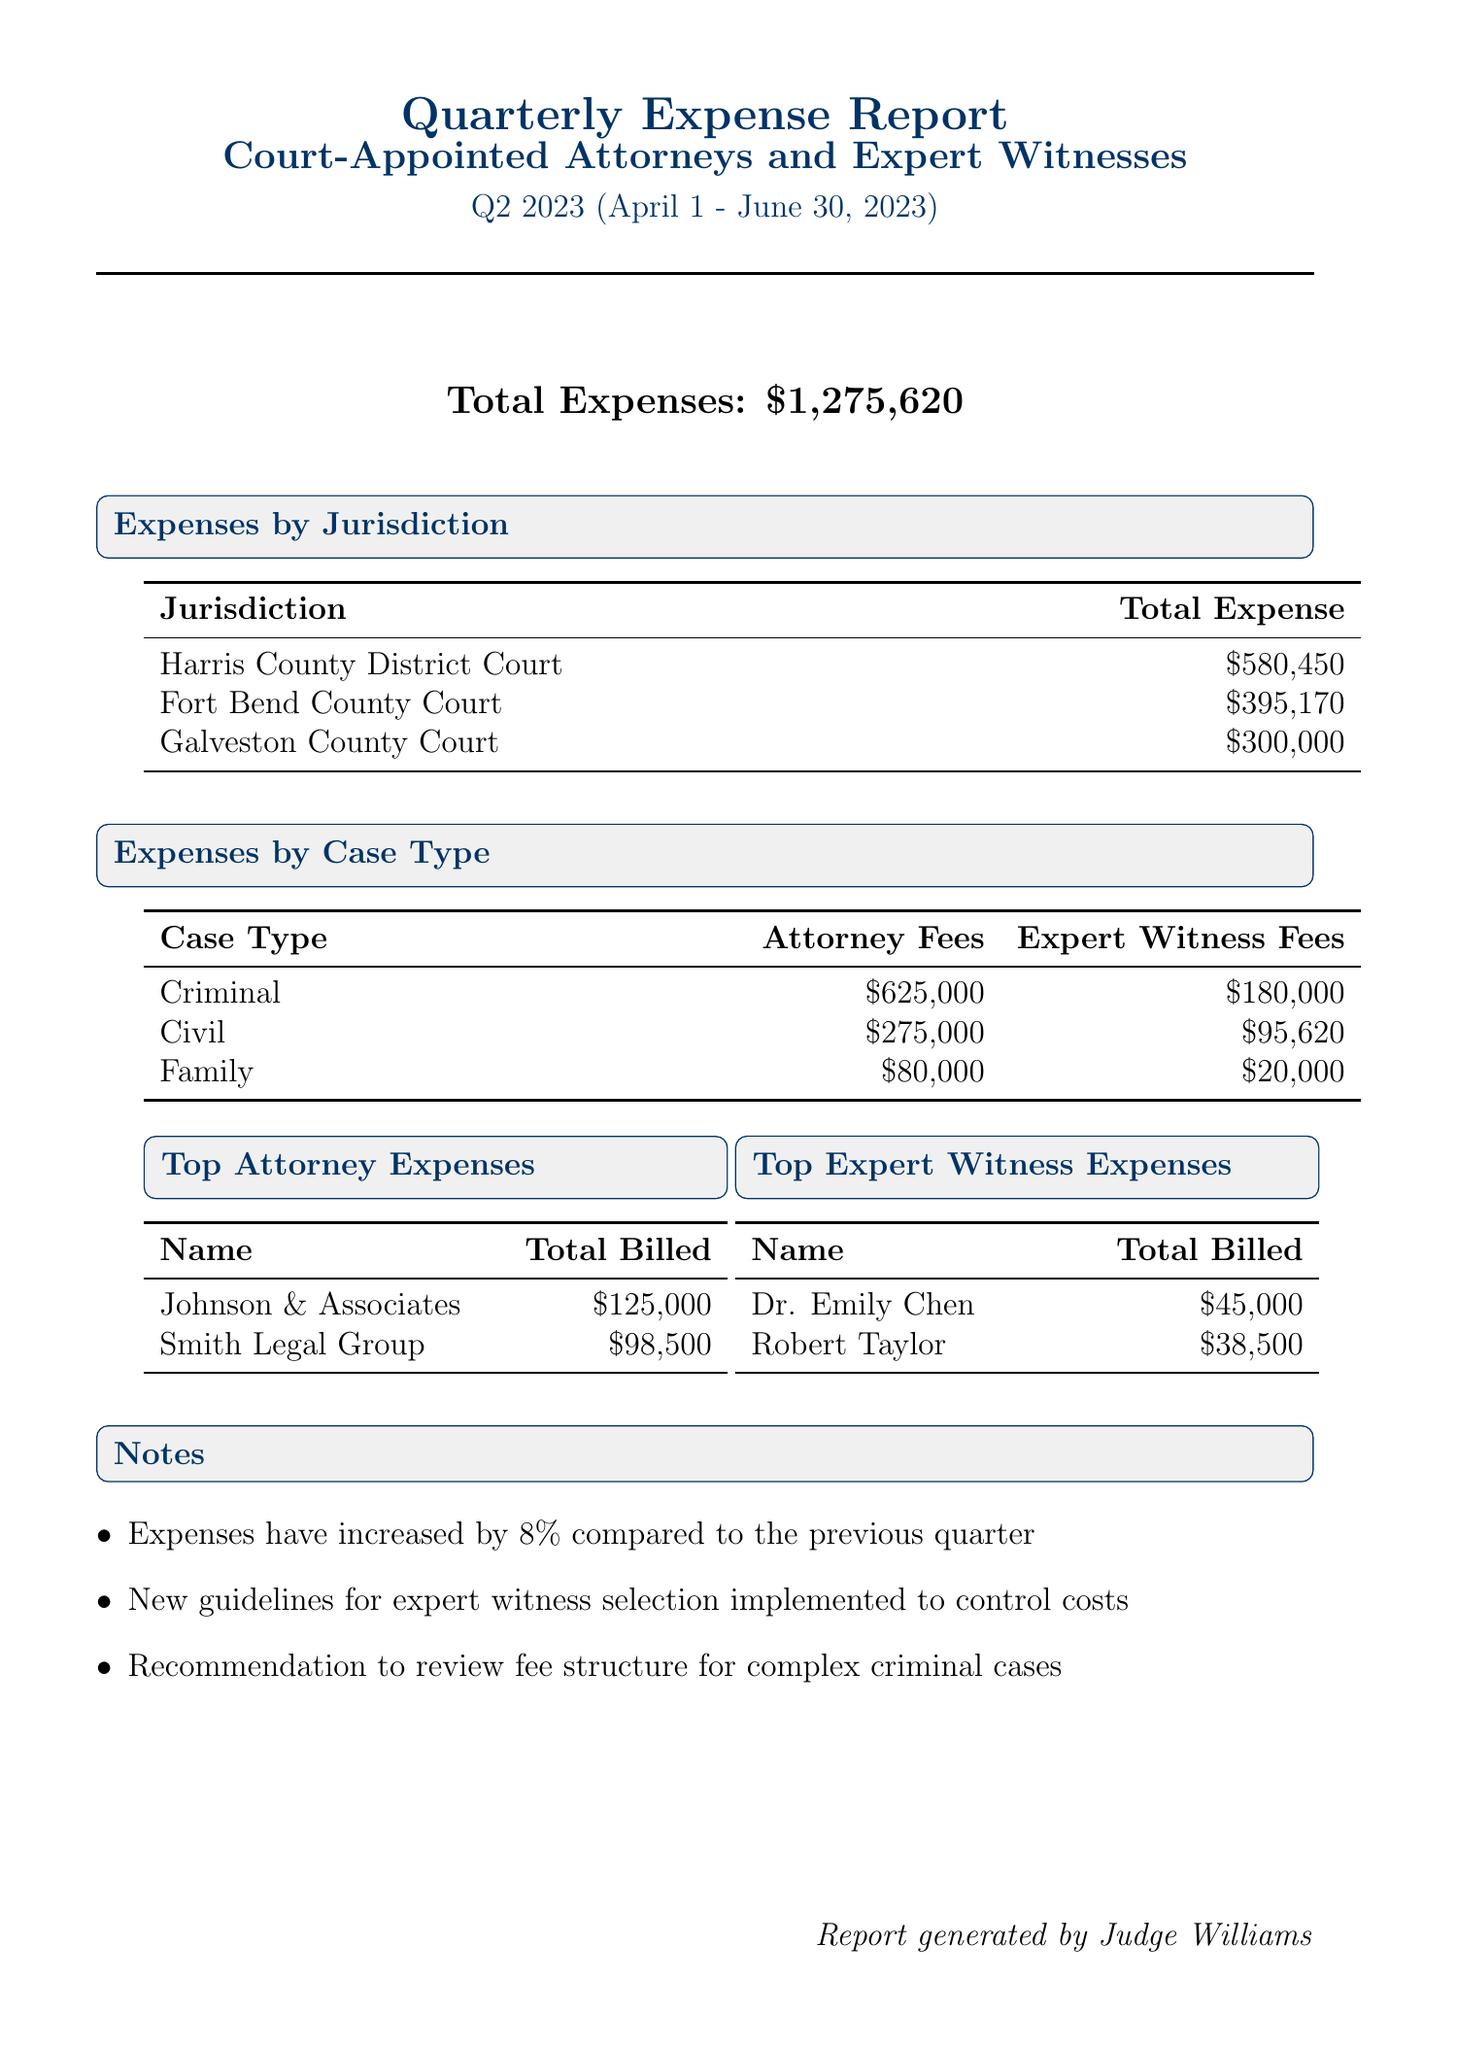What is the total expense reported for Q2 2023? The total expense reported is stated directly in the document as $1,275,620.
Answer: $1,275,620 Which jurisdiction has the highest expense? The document lists expenses by jurisdiction, with Harris County District Court having the highest total expense of $580,450.
Answer: Harris County District Court What are the total attorney fees for criminal cases? The attorney fees for criminal cases are given in the expenses by case type, totaling $625,000.
Answer: $625,000 How much was billed by Johnson & Associates? Johnson & Associates' billing is reported as $125,000 in the top attorney expenses section.
Answer: $125,000 What is the percentage increase in expenses compared to the previous quarter? The document notes that expenses have increased by 8% compared to the previous quarter.
Answer: 8% What is the total expert witness fee for civil cases? In the report, the expert witness fees for civil cases are specified as $95,620.
Answer: $95,620 Which case type has the lowest attorney fees? The case types are listed with their respective attorney fees, revealing that Family cases have the lowest fees at $80,000.
Answer: Family Who is the top-billed expert witness? The top-billed expert witness is identified in the document as Dr. Emily Chen, with a billing of $45,000.
Answer: Dr. Emily Chen What is mentioned in the notes regarding expert witness selection? The notes state that new guidelines for expert witness selection have been implemented to control costs.
Answer: New guidelines for expert witness selection 